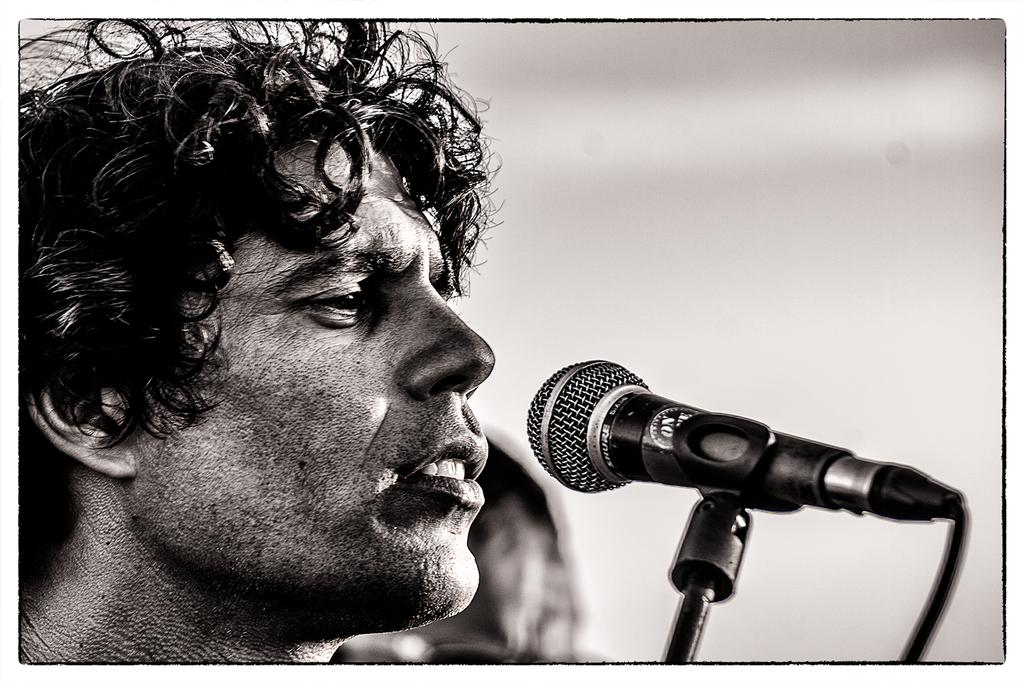What is the color scheme of the image? The image is black and white. Who is present in the image? There is a man in the image. What object is in front of the man? There is a microphone with a stand in front of the man. Can you describe the background of the image? The background of the image is blurred. What type of pet is sitting next to the man in the image? There is no pet present in the image; it only features a man and a microphone with a stand. How does the man defend himself from the attack in the image? There is no attack present in the image; it is a man standing in front of a microphone with a stand. 